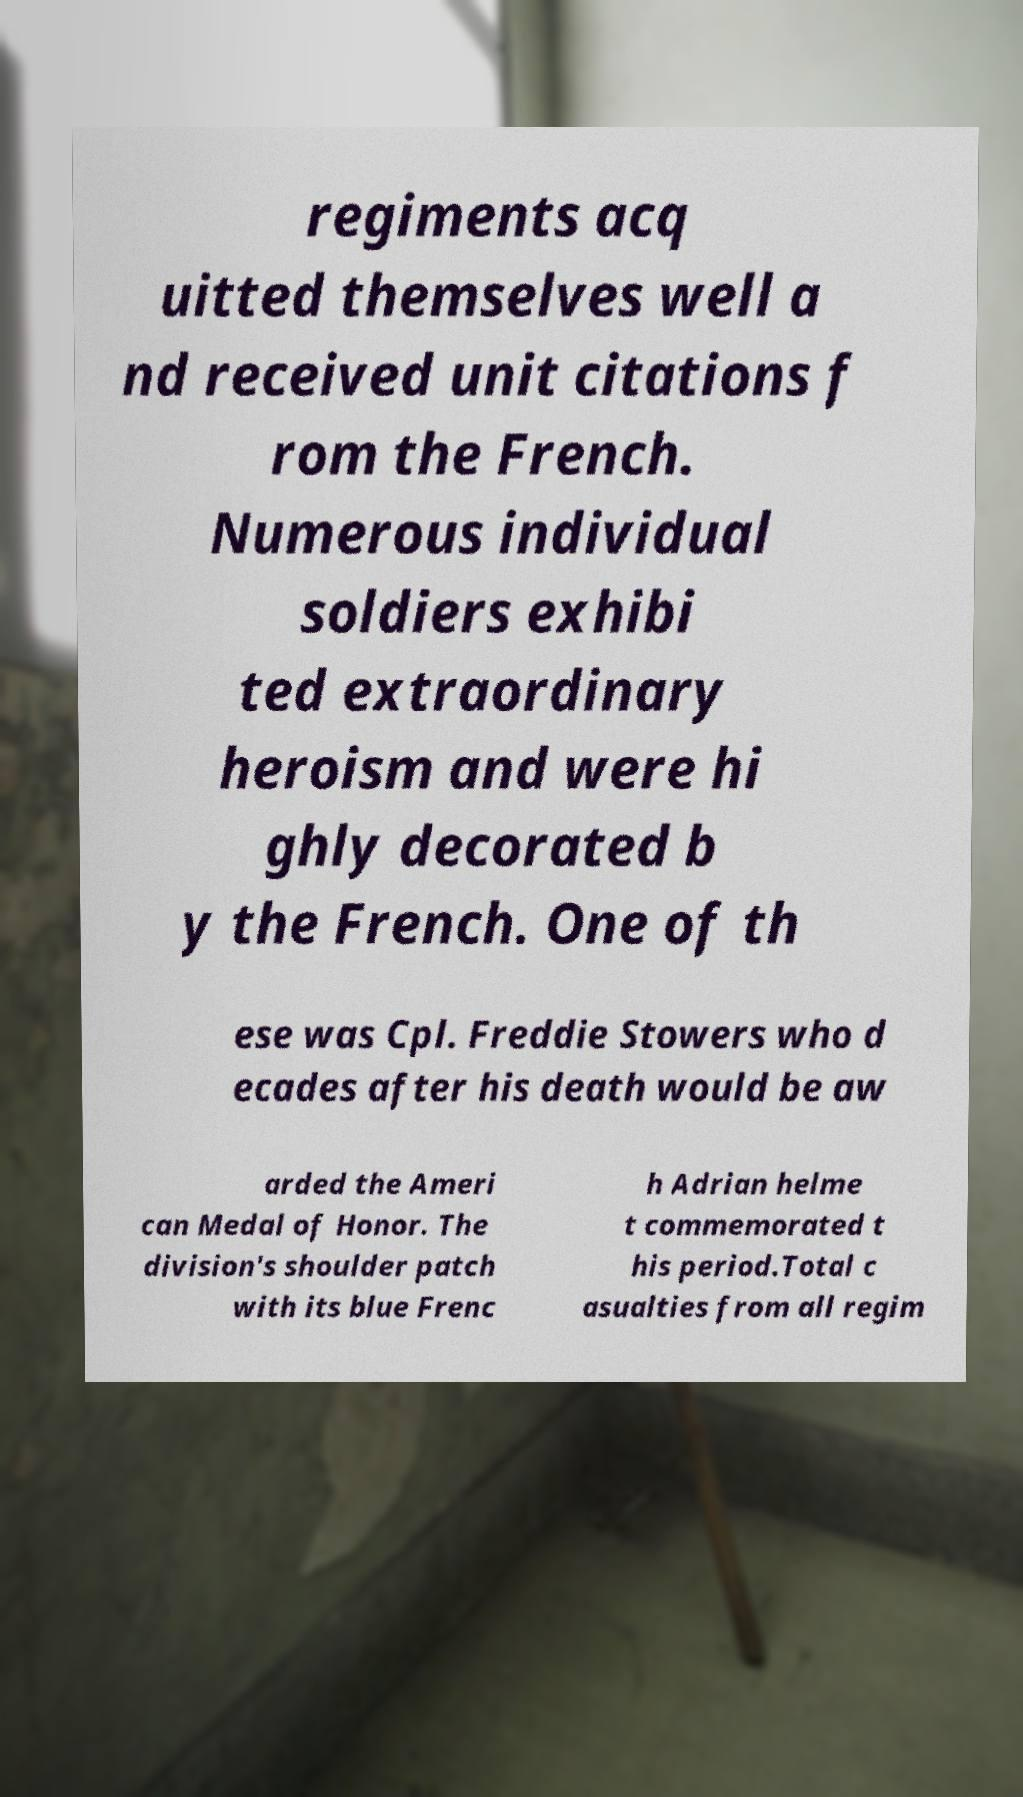What messages or text are displayed in this image? I need them in a readable, typed format. regiments acq uitted themselves well a nd received unit citations f rom the French. Numerous individual soldiers exhibi ted extraordinary heroism and were hi ghly decorated b y the French. One of th ese was Cpl. Freddie Stowers who d ecades after his death would be aw arded the Ameri can Medal of Honor. The division's shoulder patch with its blue Frenc h Adrian helme t commemorated t his period.Total c asualties from all regim 